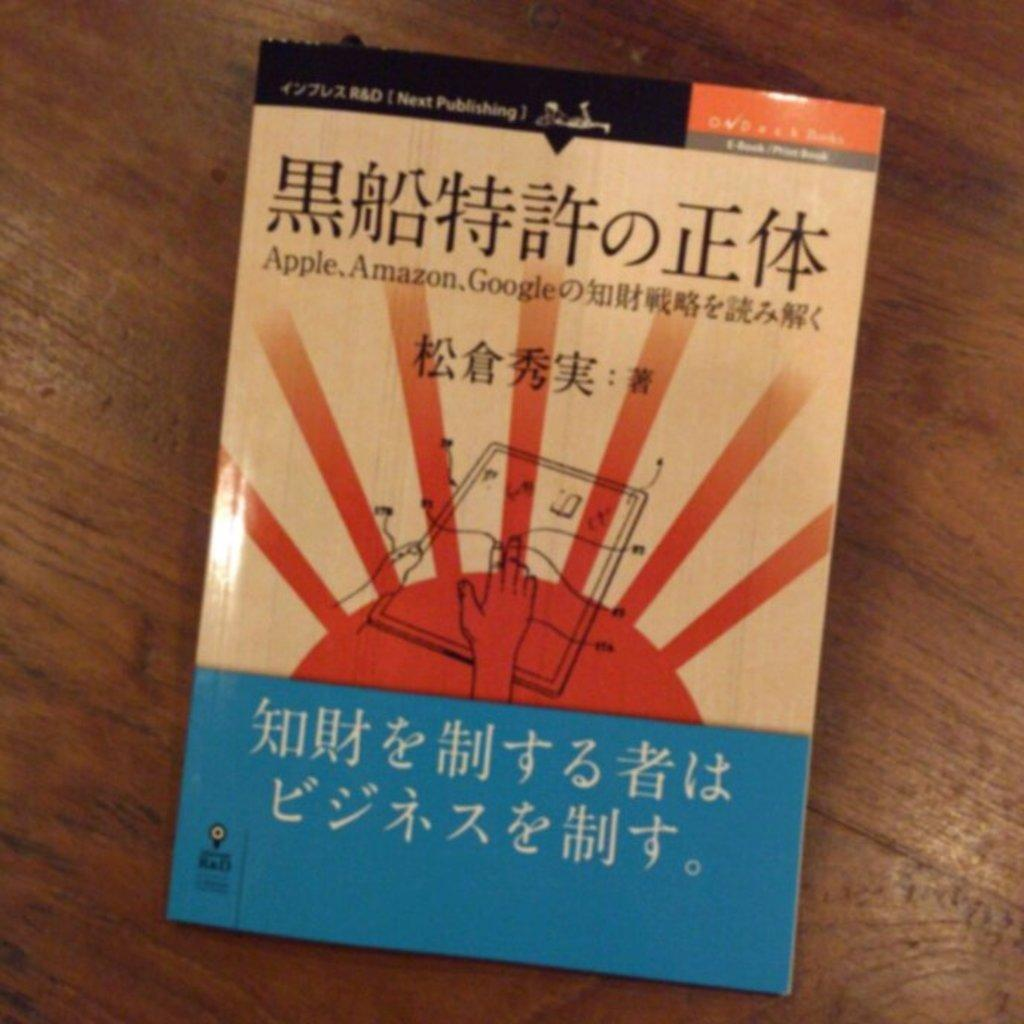Provide a one-sentence caption for the provided image. A blue and tan book with Mandarin written on the cover. 